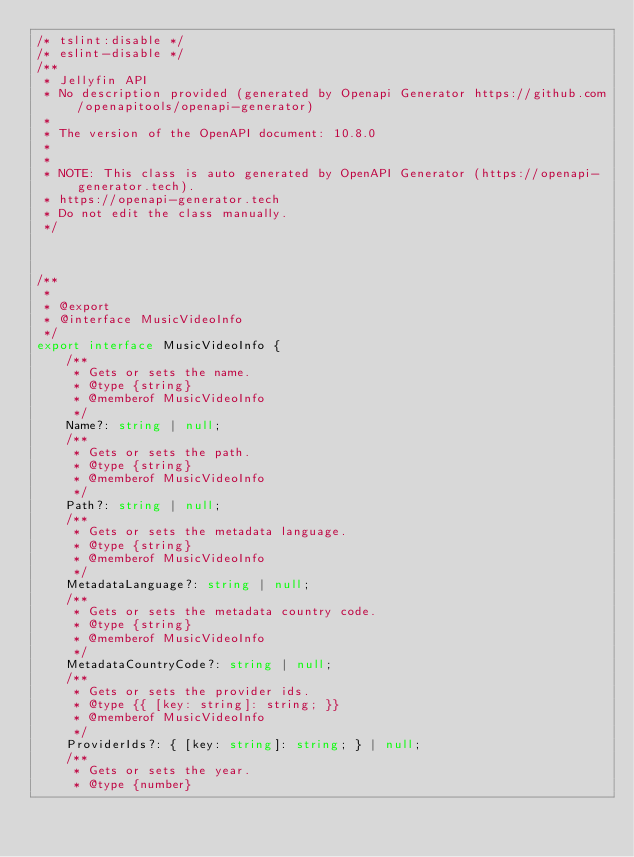<code> <loc_0><loc_0><loc_500><loc_500><_TypeScript_>/* tslint:disable */
/* eslint-disable */
/**
 * Jellyfin API
 * No description provided (generated by Openapi Generator https://github.com/openapitools/openapi-generator)
 *
 * The version of the OpenAPI document: 10.8.0
 * 
 *
 * NOTE: This class is auto generated by OpenAPI Generator (https://openapi-generator.tech).
 * https://openapi-generator.tech
 * Do not edit the class manually.
 */



/**
 * 
 * @export
 * @interface MusicVideoInfo
 */
export interface MusicVideoInfo {
    /**
     * Gets or sets the name.
     * @type {string}
     * @memberof MusicVideoInfo
     */
    Name?: string | null;
    /**
     * Gets or sets the path.
     * @type {string}
     * @memberof MusicVideoInfo
     */
    Path?: string | null;
    /**
     * Gets or sets the metadata language.
     * @type {string}
     * @memberof MusicVideoInfo
     */
    MetadataLanguage?: string | null;
    /**
     * Gets or sets the metadata country code.
     * @type {string}
     * @memberof MusicVideoInfo
     */
    MetadataCountryCode?: string | null;
    /**
     * Gets or sets the provider ids.
     * @type {{ [key: string]: string; }}
     * @memberof MusicVideoInfo
     */
    ProviderIds?: { [key: string]: string; } | null;
    /**
     * Gets or sets the year.
     * @type {number}</code> 